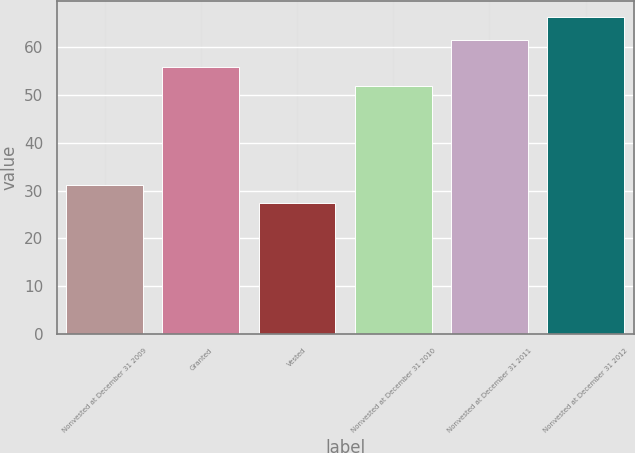Convert chart to OTSL. <chart><loc_0><loc_0><loc_500><loc_500><bar_chart><fcel>Nonvested at December 31 2009<fcel>Granted<fcel>Vested<fcel>Nonvested at December 31 2010<fcel>Nonvested at December 31 2011<fcel>Nonvested at December 31 2012<nl><fcel>31.24<fcel>55.85<fcel>27.33<fcel>51.94<fcel>61.49<fcel>66.43<nl></chart> 